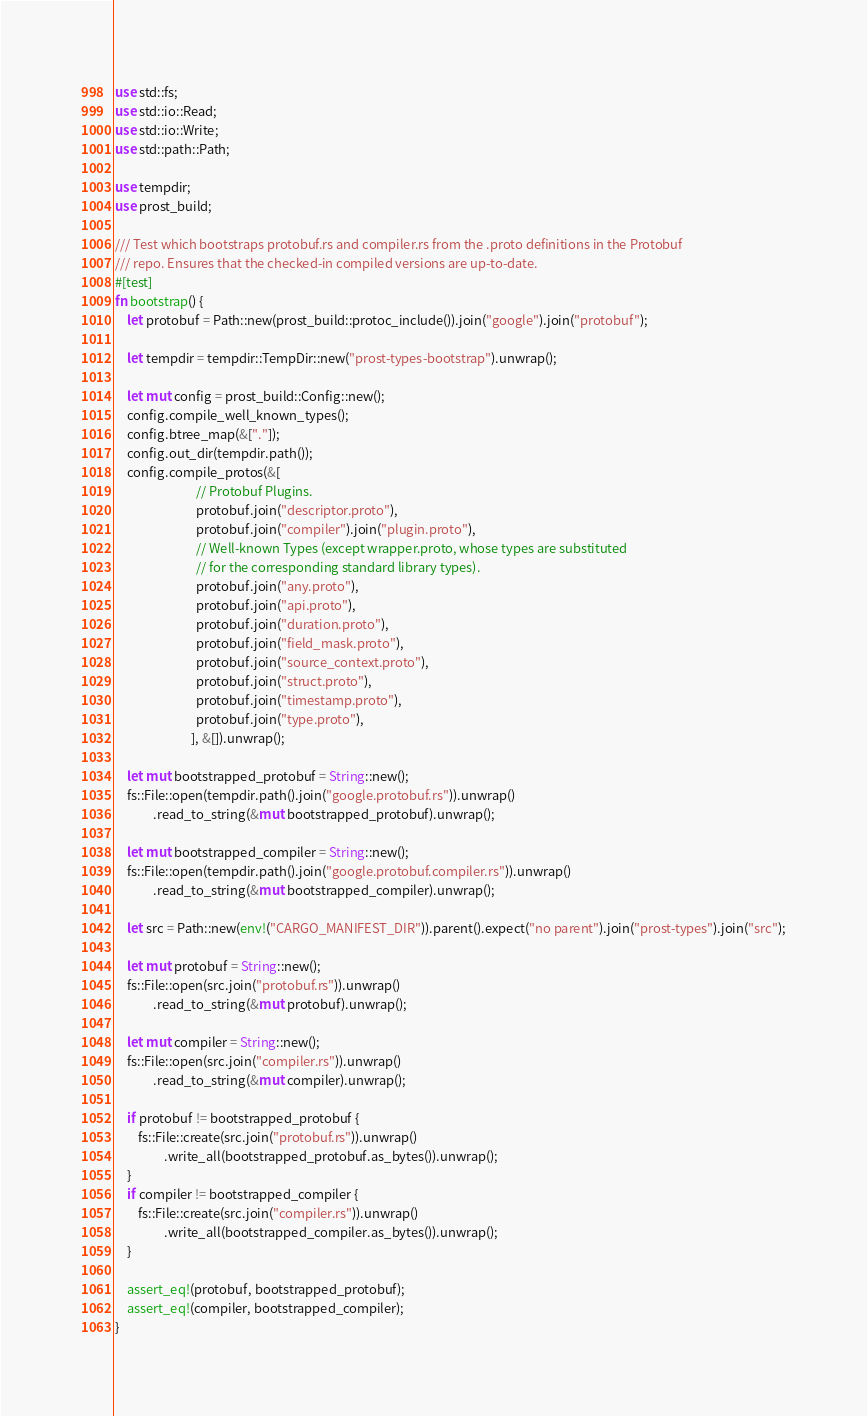<code> <loc_0><loc_0><loc_500><loc_500><_Rust_>use std::fs;
use std::io::Read;
use std::io::Write;
use std::path::Path;

use tempdir;
use prost_build;

/// Test which bootstraps protobuf.rs and compiler.rs from the .proto definitions in the Protobuf
/// repo. Ensures that the checked-in compiled versions are up-to-date.
#[test]
fn bootstrap() {
    let protobuf = Path::new(prost_build::protoc_include()).join("google").join("protobuf");

    let tempdir = tempdir::TempDir::new("prost-types-bootstrap").unwrap();

    let mut config = prost_build::Config::new();
    config.compile_well_known_types();
    config.btree_map(&["."]);
    config.out_dir(tempdir.path());
    config.compile_protos(&[
                            // Protobuf Plugins.
                            protobuf.join("descriptor.proto"),
                            protobuf.join("compiler").join("plugin.proto"),
                            // Well-known Types (except wrapper.proto, whose types are substituted
                            // for the corresponding standard library types).
                            protobuf.join("any.proto"),
                            protobuf.join("api.proto"),
                            protobuf.join("duration.proto"),
                            protobuf.join("field_mask.proto"),
                            protobuf.join("source_context.proto"),
                            protobuf.join("struct.proto"),
                            protobuf.join("timestamp.proto"),
                            protobuf.join("type.proto"),
                          ], &[]).unwrap();

    let mut bootstrapped_protobuf = String::new();
    fs::File::open(tempdir.path().join("google.protobuf.rs")).unwrap()
             .read_to_string(&mut bootstrapped_protobuf).unwrap();

    let mut bootstrapped_compiler = String::new();
    fs::File::open(tempdir.path().join("google.protobuf.compiler.rs")).unwrap()
             .read_to_string(&mut bootstrapped_compiler).unwrap();

    let src = Path::new(env!("CARGO_MANIFEST_DIR")).parent().expect("no parent").join("prost-types").join("src");

    let mut protobuf = String::new();
    fs::File::open(src.join("protobuf.rs")).unwrap()
             .read_to_string(&mut protobuf).unwrap();

    let mut compiler = String::new();
    fs::File::open(src.join("compiler.rs")).unwrap()
             .read_to_string(&mut compiler).unwrap();

    if protobuf != bootstrapped_protobuf {
        fs::File::create(src.join("protobuf.rs")).unwrap()
                 .write_all(bootstrapped_protobuf.as_bytes()).unwrap();
    }
    if compiler != bootstrapped_compiler {
        fs::File::create(src.join("compiler.rs")).unwrap()
                 .write_all(bootstrapped_compiler.as_bytes()).unwrap();
    }

    assert_eq!(protobuf, bootstrapped_protobuf);
    assert_eq!(compiler, bootstrapped_compiler);
}
</code> 